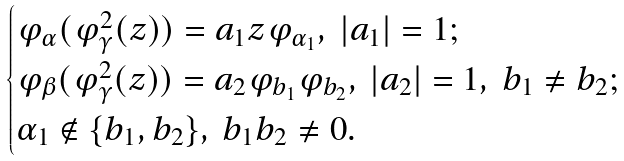Convert formula to latex. <formula><loc_0><loc_0><loc_500><loc_500>\begin{cases} \varphi _ { \alpha } ( \varphi _ { \gamma } ^ { 2 } ( z ) ) = a _ { 1 } z \varphi _ { \alpha _ { 1 } } , \ | a _ { 1 } | = 1 ; \\ \varphi _ { \beta } ( \varphi _ { \gamma } ^ { 2 } ( z ) ) = a _ { 2 } \varphi _ { b _ { 1 } } \varphi _ { b _ { 2 } } , \ | a _ { 2 } | = 1 , \ b _ { 1 } \neq b _ { 2 } ; \\ \alpha _ { 1 } \notin \{ b _ { 1 } , b _ { 2 } \} , \ b _ { 1 } b _ { 2 } \neq 0 . \end{cases}</formula> 